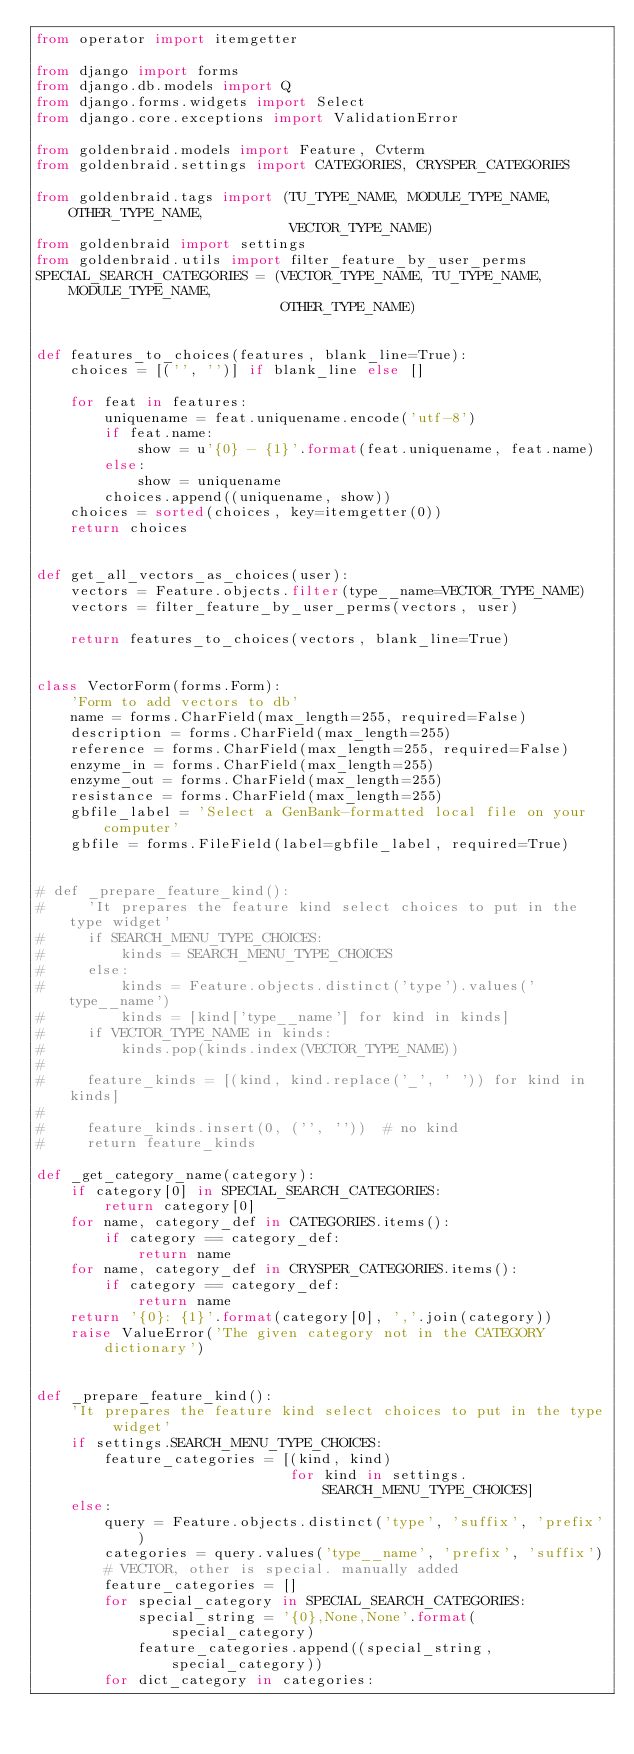Convert code to text. <code><loc_0><loc_0><loc_500><loc_500><_Python_>from operator import itemgetter

from django import forms
from django.db.models import Q
from django.forms.widgets import Select
from django.core.exceptions import ValidationError

from goldenbraid.models import Feature, Cvterm
from goldenbraid.settings import CATEGORIES, CRYSPER_CATEGORIES

from goldenbraid.tags import (TU_TYPE_NAME, MODULE_TYPE_NAME, OTHER_TYPE_NAME,
                              VECTOR_TYPE_NAME)
from goldenbraid import settings
from goldenbraid.utils import filter_feature_by_user_perms
SPECIAL_SEARCH_CATEGORIES = (VECTOR_TYPE_NAME, TU_TYPE_NAME, MODULE_TYPE_NAME,
                             OTHER_TYPE_NAME)


def features_to_choices(features, blank_line=True):
    choices = [('', '')] if blank_line else []

    for feat in features:
        uniquename = feat.uniquename.encode('utf-8')
        if feat.name:
            show = u'{0} - {1}'.format(feat.uniquename, feat.name)
        else:
            show = uniquename
        choices.append((uniquename, show))
    choices = sorted(choices, key=itemgetter(0))
    return choices


def get_all_vectors_as_choices(user):
    vectors = Feature.objects.filter(type__name=VECTOR_TYPE_NAME)
    vectors = filter_feature_by_user_perms(vectors, user)

    return features_to_choices(vectors, blank_line=True)


class VectorForm(forms.Form):
    'Form to add vectors to db'
    name = forms.CharField(max_length=255, required=False)
    description = forms.CharField(max_length=255)
    reference = forms.CharField(max_length=255, required=False)
    enzyme_in = forms.CharField(max_length=255)
    enzyme_out = forms.CharField(max_length=255)
    resistance = forms.CharField(max_length=255)
    gbfile_label = 'Select a GenBank-formatted local file on your computer'
    gbfile = forms.FileField(label=gbfile_label, required=True)


# def _prepare_feature_kind():
#     'It prepares the feature kind select choices to put in the type widget'
#     if SEARCH_MENU_TYPE_CHOICES:
#         kinds = SEARCH_MENU_TYPE_CHOICES
#     else:
#         kinds = Feature.objects.distinct('type').values('type__name')
#         kinds = [kind['type__name'] for kind in kinds]
#     if VECTOR_TYPE_NAME in kinds:
#         kinds.pop(kinds.index(VECTOR_TYPE_NAME))
#
#     feature_kinds = [(kind, kind.replace('_', ' ')) for kind in kinds]
#
#     feature_kinds.insert(0, ('', ''))  # no kind
#     return feature_kinds

def _get_category_name(category):
    if category[0] in SPECIAL_SEARCH_CATEGORIES:
        return category[0]
    for name, category_def in CATEGORIES.items():
        if category == category_def:
            return name
    for name, category_def in CRYSPER_CATEGORIES.items():
        if category == category_def:
            return name
    return '{0}: {1}'.format(category[0], ','.join(category))
    raise ValueError('The given category not in the CATEGORY dictionary')


def _prepare_feature_kind():
    'It prepares the feature kind select choices to put in the type widget'
    if settings.SEARCH_MENU_TYPE_CHOICES:
        feature_categories = [(kind, kind)
                              for kind in settings.SEARCH_MENU_TYPE_CHOICES]
    else:
        query = Feature.objects.distinct('type', 'suffix', 'prefix')
        categories = query.values('type__name', 'prefix', 'suffix')
        # VECTOR, other is special. manually added
        feature_categories = []
        for special_category in SPECIAL_SEARCH_CATEGORIES:
            special_string = '{0},None,None'.format(special_category)
            feature_categories.append((special_string, special_category))
        for dict_category in categories:</code> 